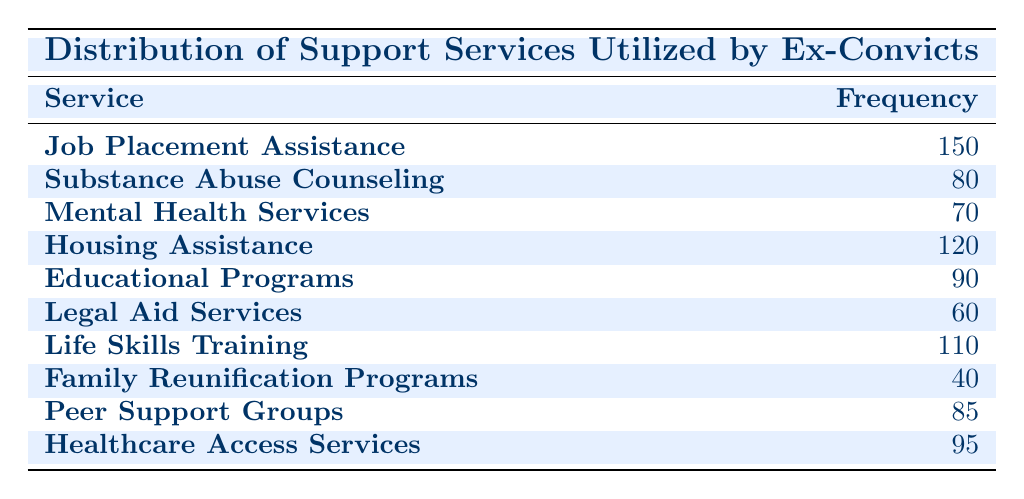What is the most utilized support service? By examining the frequency values in the table, "Job Placement Assistance" has the highest frequency at 150, making it the most utilized service.
Answer: Job Placement Assistance How many ex-convicts utilized Housing Assistance? The table lists the frequency for "Housing Assistance" as 120, indicating that 120 ex-convicts utilized this service.
Answer: 120 What is the total frequency of all support services? Adding all the frequencies together: 150 + 80 + 70 + 120 + 90 + 60 + 110 + 40 + 85 + 95 totals to 1,000.
Answer: 1000 Is the frequency for Legal Aid Services greater than 75? The frequency for "Legal Aid Services" is 60, which is less than 75, making this statement false.
Answer: No What is the average frequency of the support services that include counseling? The relevant services that include counseling are "Substance Abuse Counseling" (80) and "Mental Health Services" (70). The average is calculated as (80 + 70) / 2 = 75.
Answer: 75 Which service had the lowest utilization, and what was the frequency? The service with the lowest frequency is "Family Reunification Programs," with a frequency of 40, identified by comparing all frequency values in the table.
Answer: Family Reunification Programs, 40 How many more ex-convicts utilized Job Placement Assistance than those who utilized Peer Support Groups? The difference in frequency is calculated by subtracting the frequency of "Peer Support Groups" (85) from "Job Placement Assistance" (150): 150 - 85 = 65.
Answer: 65 Which services had a frequency above 100? The services with a frequency above 100 are "Job Placement Assistance" (150), "Housing Assistance" (120), and "Life Skills Training" (110). Therefore, three services meet this criteria.
Answer: 3 How many services were utilized by fewer than 80 ex-convicts? The services that fall below this threshold are "Mental Health Services" (70), "Legal Aid Services" (60), and "Family Reunification Programs" (40), totaling three services.
Answer: 3 